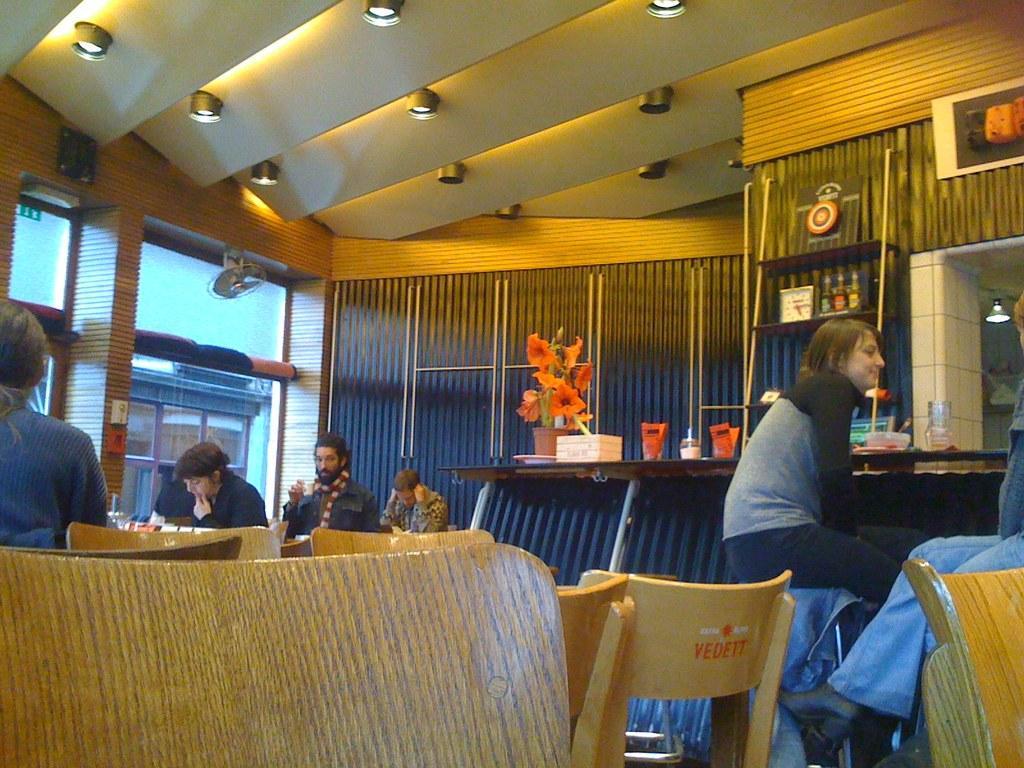How would you summarize this image in a sentence or two? This picture is an inside view of a room. In this we can see some persons are sitting on a chair. In the center of the image there is a table. On the table plant, pot, box, glass and some objects. In the background of the image we can see windows, fan, wall, shelves, clock, light, board. At the top of the image we can see roof, lights. 